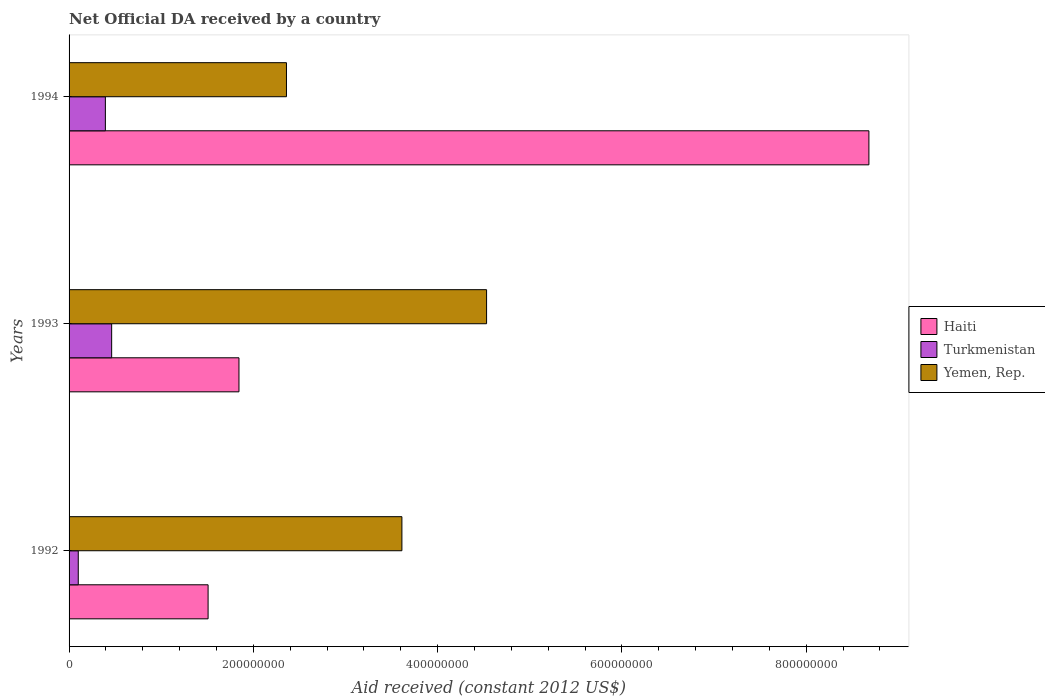How many different coloured bars are there?
Make the answer very short. 3. How many groups of bars are there?
Keep it short and to the point. 3. Are the number of bars per tick equal to the number of legend labels?
Ensure brevity in your answer.  Yes. Are the number of bars on each tick of the Y-axis equal?
Keep it short and to the point. Yes. How many bars are there on the 3rd tick from the top?
Provide a succinct answer. 3. How many bars are there on the 2nd tick from the bottom?
Ensure brevity in your answer.  3. What is the net official development assistance aid received in Yemen, Rep. in 1994?
Provide a succinct answer. 2.36e+08. Across all years, what is the maximum net official development assistance aid received in Haiti?
Keep it short and to the point. 8.68e+08. Across all years, what is the minimum net official development assistance aid received in Yemen, Rep.?
Provide a succinct answer. 2.36e+08. In which year was the net official development assistance aid received in Haiti maximum?
Your response must be concise. 1994. What is the total net official development assistance aid received in Turkmenistan in the graph?
Provide a succinct answer. 9.56e+07. What is the difference between the net official development assistance aid received in Haiti in 1993 and that in 1994?
Provide a short and direct response. -6.84e+08. What is the difference between the net official development assistance aid received in Haiti in 1993 and the net official development assistance aid received in Turkmenistan in 1992?
Give a very brief answer. 1.74e+08. What is the average net official development assistance aid received in Yemen, Rep. per year?
Give a very brief answer. 3.50e+08. In the year 1992, what is the difference between the net official development assistance aid received in Yemen, Rep. and net official development assistance aid received in Turkmenistan?
Give a very brief answer. 3.51e+08. What is the ratio of the net official development assistance aid received in Yemen, Rep. in 1992 to that in 1993?
Make the answer very short. 0.8. Is the net official development assistance aid received in Turkmenistan in 1993 less than that in 1994?
Provide a succinct answer. No. What is the difference between the highest and the second highest net official development assistance aid received in Yemen, Rep.?
Your response must be concise. 9.19e+07. What is the difference between the highest and the lowest net official development assistance aid received in Turkmenistan?
Make the answer very short. 3.62e+07. Is the sum of the net official development assistance aid received in Yemen, Rep. in 1992 and 1993 greater than the maximum net official development assistance aid received in Haiti across all years?
Provide a short and direct response. No. What does the 3rd bar from the top in 1992 represents?
Make the answer very short. Haiti. What does the 2nd bar from the bottom in 1994 represents?
Your answer should be very brief. Turkmenistan. Is it the case that in every year, the sum of the net official development assistance aid received in Turkmenistan and net official development assistance aid received in Yemen, Rep. is greater than the net official development assistance aid received in Haiti?
Ensure brevity in your answer.  No. How many bars are there?
Your answer should be very brief. 9. Are all the bars in the graph horizontal?
Ensure brevity in your answer.  Yes. Are the values on the major ticks of X-axis written in scientific E-notation?
Ensure brevity in your answer.  No. How many legend labels are there?
Give a very brief answer. 3. What is the title of the graph?
Make the answer very short. Net Official DA received by a country. Does "United Arab Emirates" appear as one of the legend labels in the graph?
Provide a succinct answer. No. What is the label or title of the X-axis?
Keep it short and to the point. Aid received (constant 2012 US$). What is the Aid received (constant 2012 US$) of Haiti in 1992?
Provide a succinct answer. 1.51e+08. What is the Aid received (constant 2012 US$) of Turkmenistan in 1992?
Make the answer very short. 9.98e+06. What is the Aid received (constant 2012 US$) of Yemen, Rep. in 1992?
Give a very brief answer. 3.61e+08. What is the Aid received (constant 2012 US$) of Haiti in 1993?
Provide a succinct answer. 1.84e+08. What is the Aid received (constant 2012 US$) of Turkmenistan in 1993?
Ensure brevity in your answer.  4.62e+07. What is the Aid received (constant 2012 US$) of Yemen, Rep. in 1993?
Make the answer very short. 4.53e+08. What is the Aid received (constant 2012 US$) of Haiti in 1994?
Your response must be concise. 8.68e+08. What is the Aid received (constant 2012 US$) in Turkmenistan in 1994?
Make the answer very short. 3.94e+07. What is the Aid received (constant 2012 US$) in Yemen, Rep. in 1994?
Make the answer very short. 2.36e+08. Across all years, what is the maximum Aid received (constant 2012 US$) in Haiti?
Your response must be concise. 8.68e+08. Across all years, what is the maximum Aid received (constant 2012 US$) in Turkmenistan?
Ensure brevity in your answer.  4.62e+07. Across all years, what is the maximum Aid received (constant 2012 US$) of Yemen, Rep.?
Ensure brevity in your answer.  4.53e+08. Across all years, what is the minimum Aid received (constant 2012 US$) of Haiti?
Provide a succinct answer. 1.51e+08. Across all years, what is the minimum Aid received (constant 2012 US$) of Turkmenistan?
Your response must be concise. 9.98e+06. Across all years, what is the minimum Aid received (constant 2012 US$) of Yemen, Rep.?
Your answer should be very brief. 2.36e+08. What is the total Aid received (constant 2012 US$) in Haiti in the graph?
Provide a short and direct response. 1.20e+09. What is the total Aid received (constant 2012 US$) in Turkmenistan in the graph?
Your answer should be compact. 9.56e+07. What is the total Aid received (constant 2012 US$) in Yemen, Rep. in the graph?
Your response must be concise. 1.05e+09. What is the difference between the Aid received (constant 2012 US$) of Haiti in 1992 and that in 1993?
Your response must be concise. -3.35e+07. What is the difference between the Aid received (constant 2012 US$) of Turkmenistan in 1992 and that in 1993?
Offer a very short reply. -3.62e+07. What is the difference between the Aid received (constant 2012 US$) of Yemen, Rep. in 1992 and that in 1993?
Offer a very short reply. -9.19e+07. What is the difference between the Aid received (constant 2012 US$) of Haiti in 1992 and that in 1994?
Your answer should be very brief. -7.17e+08. What is the difference between the Aid received (constant 2012 US$) in Turkmenistan in 1992 and that in 1994?
Make the answer very short. -2.94e+07. What is the difference between the Aid received (constant 2012 US$) in Yemen, Rep. in 1992 and that in 1994?
Provide a succinct answer. 1.25e+08. What is the difference between the Aid received (constant 2012 US$) in Haiti in 1993 and that in 1994?
Make the answer very short. -6.84e+08. What is the difference between the Aid received (constant 2012 US$) in Turkmenistan in 1993 and that in 1994?
Provide a short and direct response. 6.81e+06. What is the difference between the Aid received (constant 2012 US$) of Yemen, Rep. in 1993 and that in 1994?
Provide a short and direct response. 2.17e+08. What is the difference between the Aid received (constant 2012 US$) of Haiti in 1992 and the Aid received (constant 2012 US$) of Turkmenistan in 1993?
Your answer should be very brief. 1.05e+08. What is the difference between the Aid received (constant 2012 US$) in Haiti in 1992 and the Aid received (constant 2012 US$) in Yemen, Rep. in 1993?
Ensure brevity in your answer.  -3.02e+08. What is the difference between the Aid received (constant 2012 US$) in Turkmenistan in 1992 and the Aid received (constant 2012 US$) in Yemen, Rep. in 1993?
Offer a very short reply. -4.43e+08. What is the difference between the Aid received (constant 2012 US$) of Haiti in 1992 and the Aid received (constant 2012 US$) of Turkmenistan in 1994?
Give a very brief answer. 1.11e+08. What is the difference between the Aid received (constant 2012 US$) of Haiti in 1992 and the Aid received (constant 2012 US$) of Yemen, Rep. in 1994?
Your answer should be very brief. -8.50e+07. What is the difference between the Aid received (constant 2012 US$) in Turkmenistan in 1992 and the Aid received (constant 2012 US$) in Yemen, Rep. in 1994?
Provide a short and direct response. -2.26e+08. What is the difference between the Aid received (constant 2012 US$) in Haiti in 1993 and the Aid received (constant 2012 US$) in Turkmenistan in 1994?
Give a very brief answer. 1.45e+08. What is the difference between the Aid received (constant 2012 US$) in Haiti in 1993 and the Aid received (constant 2012 US$) in Yemen, Rep. in 1994?
Ensure brevity in your answer.  -5.15e+07. What is the difference between the Aid received (constant 2012 US$) of Turkmenistan in 1993 and the Aid received (constant 2012 US$) of Yemen, Rep. in 1994?
Give a very brief answer. -1.90e+08. What is the average Aid received (constant 2012 US$) of Haiti per year?
Provide a succinct answer. 4.01e+08. What is the average Aid received (constant 2012 US$) of Turkmenistan per year?
Your answer should be very brief. 3.19e+07. What is the average Aid received (constant 2012 US$) of Yemen, Rep. per year?
Offer a terse response. 3.50e+08. In the year 1992, what is the difference between the Aid received (constant 2012 US$) in Haiti and Aid received (constant 2012 US$) in Turkmenistan?
Offer a very short reply. 1.41e+08. In the year 1992, what is the difference between the Aid received (constant 2012 US$) in Haiti and Aid received (constant 2012 US$) in Yemen, Rep.?
Offer a very short reply. -2.10e+08. In the year 1992, what is the difference between the Aid received (constant 2012 US$) in Turkmenistan and Aid received (constant 2012 US$) in Yemen, Rep.?
Your answer should be compact. -3.51e+08. In the year 1993, what is the difference between the Aid received (constant 2012 US$) of Haiti and Aid received (constant 2012 US$) of Turkmenistan?
Ensure brevity in your answer.  1.38e+08. In the year 1993, what is the difference between the Aid received (constant 2012 US$) in Haiti and Aid received (constant 2012 US$) in Yemen, Rep.?
Your response must be concise. -2.69e+08. In the year 1993, what is the difference between the Aid received (constant 2012 US$) in Turkmenistan and Aid received (constant 2012 US$) in Yemen, Rep.?
Provide a succinct answer. -4.07e+08. In the year 1994, what is the difference between the Aid received (constant 2012 US$) in Haiti and Aid received (constant 2012 US$) in Turkmenistan?
Provide a succinct answer. 8.29e+08. In the year 1994, what is the difference between the Aid received (constant 2012 US$) of Haiti and Aid received (constant 2012 US$) of Yemen, Rep.?
Your answer should be compact. 6.32e+08. In the year 1994, what is the difference between the Aid received (constant 2012 US$) in Turkmenistan and Aid received (constant 2012 US$) in Yemen, Rep.?
Keep it short and to the point. -1.97e+08. What is the ratio of the Aid received (constant 2012 US$) of Haiti in 1992 to that in 1993?
Make the answer very short. 0.82. What is the ratio of the Aid received (constant 2012 US$) in Turkmenistan in 1992 to that in 1993?
Ensure brevity in your answer.  0.22. What is the ratio of the Aid received (constant 2012 US$) of Yemen, Rep. in 1992 to that in 1993?
Your answer should be very brief. 0.8. What is the ratio of the Aid received (constant 2012 US$) in Haiti in 1992 to that in 1994?
Provide a short and direct response. 0.17. What is the ratio of the Aid received (constant 2012 US$) of Turkmenistan in 1992 to that in 1994?
Provide a short and direct response. 0.25. What is the ratio of the Aid received (constant 2012 US$) in Yemen, Rep. in 1992 to that in 1994?
Provide a short and direct response. 1.53. What is the ratio of the Aid received (constant 2012 US$) in Haiti in 1993 to that in 1994?
Provide a short and direct response. 0.21. What is the ratio of the Aid received (constant 2012 US$) in Turkmenistan in 1993 to that in 1994?
Ensure brevity in your answer.  1.17. What is the ratio of the Aid received (constant 2012 US$) in Yemen, Rep. in 1993 to that in 1994?
Your answer should be compact. 1.92. What is the difference between the highest and the second highest Aid received (constant 2012 US$) of Haiti?
Ensure brevity in your answer.  6.84e+08. What is the difference between the highest and the second highest Aid received (constant 2012 US$) in Turkmenistan?
Make the answer very short. 6.81e+06. What is the difference between the highest and the second highest Aid received (constant 2012 US$) of Yemen, Rep.?
Give a very brief answer. 9.19e+07. What is the difference between the highest and the lowest Aid received (constant 2012 US$) of Haiti?
Ensure brevity in your answer.  7.17e+08. What is the difference between the highest and the lowest Aid received (constant 2012 US$) in Turkmenistan?
Provide a succinct answer. 3.62e+07. What is the difference between the highest and the lowest Aid received (constant 2012 US$) of Yemen, Rep.?
Your answer should be compact. 2.17e+08. 